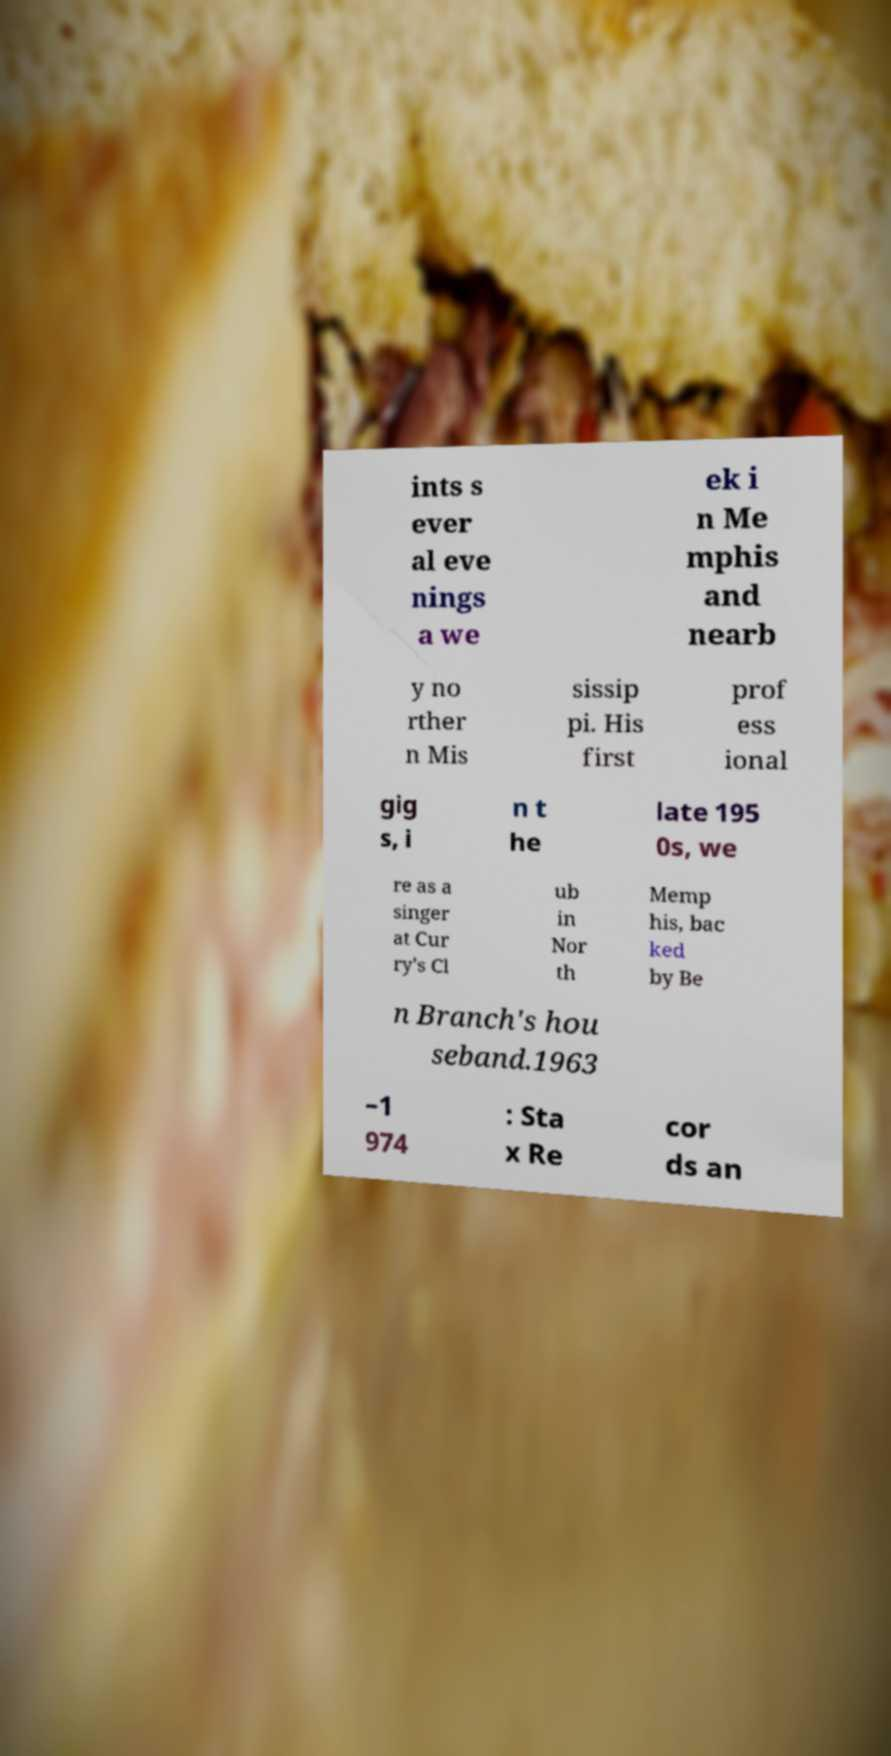Can you accurately transcribe the text from the provided image for me? ints s ever al eve nings a we ek i n Me mphis and nearb y no rther n Mis sissip pi. His first prof ess ional gig s, i n t he late 195 0s, we re as a singer at Cur ry's Cl ub in Nor th Memp his, bac ked by Be n Branch's hou seband.1963 –1 974 : Sta x Re cor ds an 